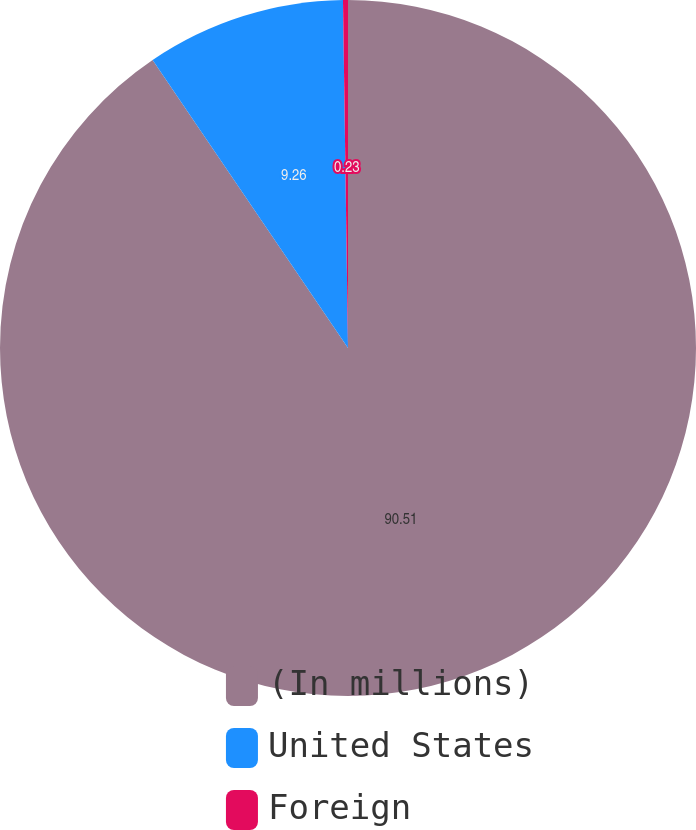<chart> <loc_0><loc_0><loc_500><loc_500><pie_chart><fcel>(In millions)<fcel>United States<fcel>Foreign<nl><fcel>90.52%<fcel>9.26%<fcel>0.23%<nl></chart> 